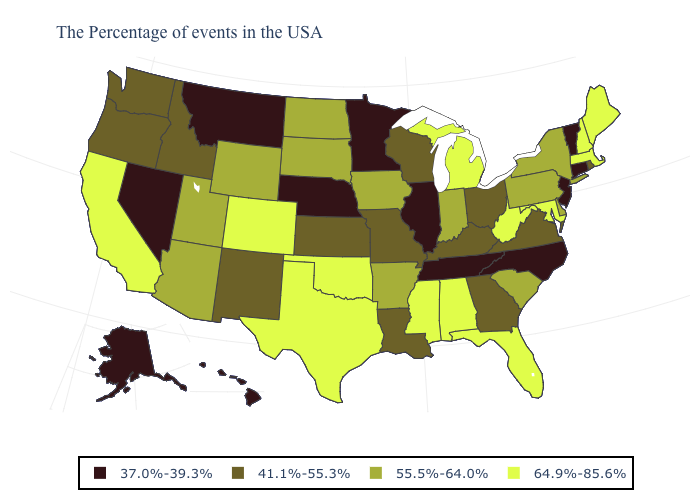Among the states that border Georgia , which have the highest value?
Answer briefly. Florida, Alabama. What is the value of Michigan?
Short answer required. 64.9%-85.6%. Does the first symbol in the legend represent the smallest category?
Short answer required. Yes. Name the states that have a value in the range 41.1%-55.3%?
Write a very short answer. Rhode Island, Virginia, Ohio, Georgia, Kentucky, Wisconsin, Louisiana, Missouri, Kansas, New Mexico, Idaho, Washington, Oregon. How many symbols are there in the legend?
Give a very brief answer. 4. Does Alaska have a higher value than Illinois?
Quick response, please. No. What is the value of Colorado?
Quick response, please. 64.9%-85.6%. Which states have the highest value in the USA?
Concise answer only. Maine, Massachusetts, New Hampshire, Maryland, West Virginia, Florida, Michigan, Alabama, Mississippi, Oklahoma, Texas, Colorado, California. Does Nebraska have the highest value in the MidWest?
Answer briefly. No. Does Alaska have the lowest value in the USA?
Write a very short answer. Yes. What is the value of Arkansas?
Give a very brief answer. 55.5%-64.0%. What is the lowest value in states that border Wyoming?
Write a very short answer. 37.0%-39.3%. What is the value of Alabama?
Quick response, please. 64.9%-85.6%. Name the states that have a value in the range 64.9%-85.6%?
Be succinct. Maine, Massachusetts, New Hampshire, Maryland, West Virginia, Florida, Michigan, Alabama, Mississippi, Oklahoma, Texas, Colorado, California. 